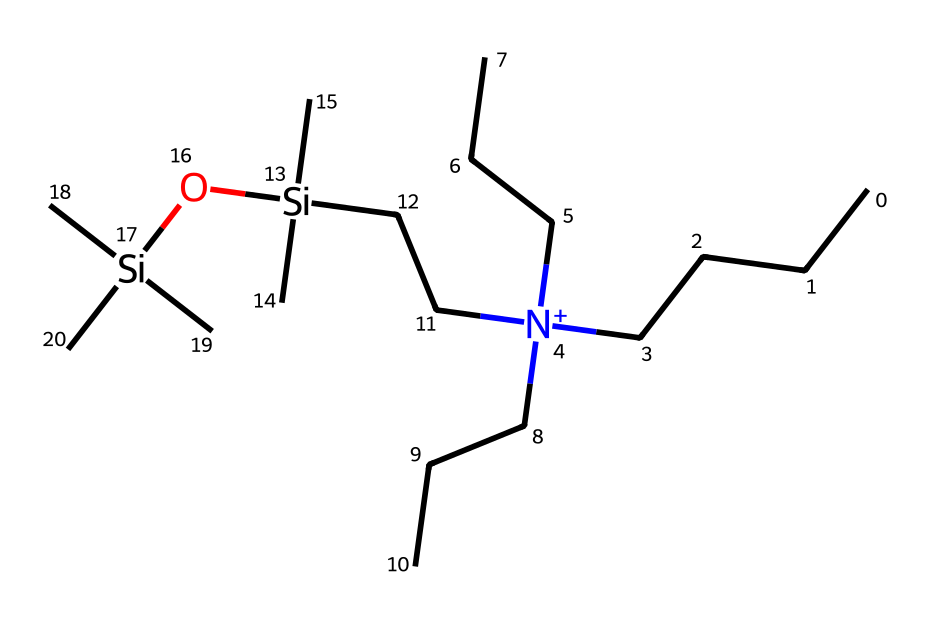What is the primary functional group present in this molecule? The molecule contains a quaternary ammonium group, indicated by the nitrogen atom bonded to four carbon chains (three ethyl groups and one larger alkyl group). This functional group is characteristic of many fabric softeners.
Answer: quaternary ammonium group How many silicon atoms are present in this chemical? The structure shows two silicon atoms, both bonded to groups of carbon. Each silicon atom connects to two methyl groups and an alcohol group, typical in silicone-based softeners.
Answer: two What do the long carbon chains contribute to the chemical properties of this fabric softener? The long carbon chains create hydrophobic regions that improve the softening properties by reducing friction between fabric fibers, enhancing softness and reducing static cling.
Answer: hydrophobic regions How many total carbon atoms can be counted in the entire molecular structure? By counting the number of carbon atoms in each alkyl and methyl chain in the structure, we find there are a total of 20 carbon atoms.
Answer: twenty What is the expected effect of the hydroxyl group in this compound? The hydroxyl group enhances the solubility of the fabric softener in water, allowing it to interact more effectively with fabric fibers during washing and rinsing cycles.
Answer: enhances solubility Is this molecule expected to be cationic, anionic, or nonionic? Given the presence of the quaternary ammonium ion, this softener is cationic, meaning it carries a positive charge in solution and is effective for fabric conditioning.
Answer: cationic 